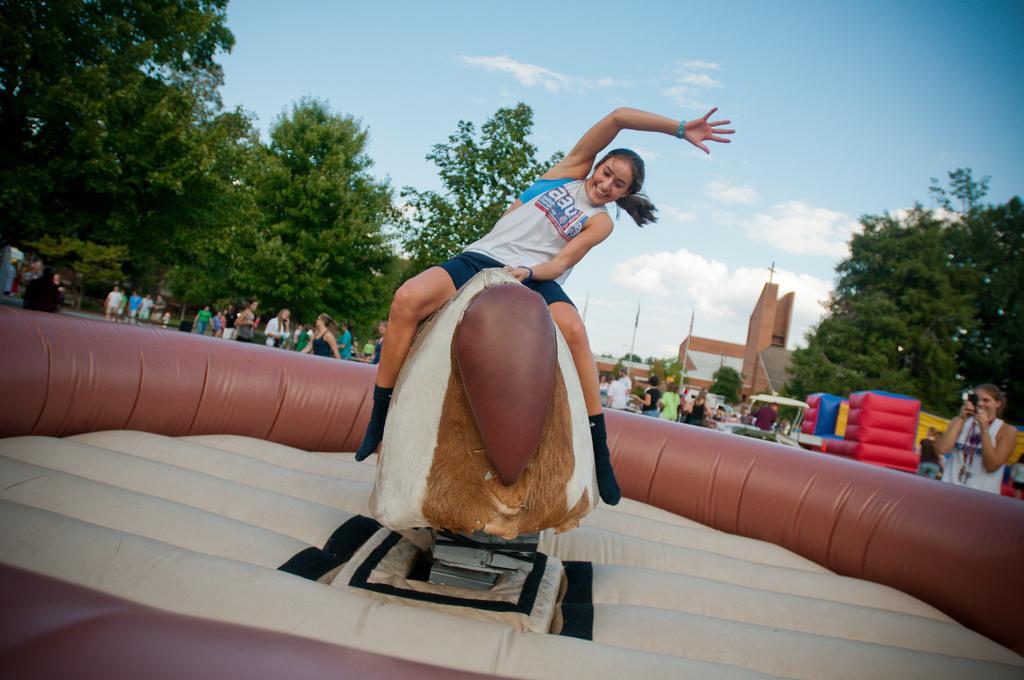Please provide a concise description of this image. In this image I can see a woman is sitting on the shaking object in the shape of an animal, she wore white color top and blue color short. On the right side a woman is shooting with a camera, she wore white color top. Beside her there are red color air balloons and there are trees. In the middle there are buildings, on the left side a group of people are walking and there are trees, at the top it is the sky. 